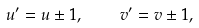<formula> <loc_0><loc_0><loc_500><loc_500>u ^ { \prime } = u \pm 1 , \quad v ^ { \prime } = v \pm 1 ,</formula> 